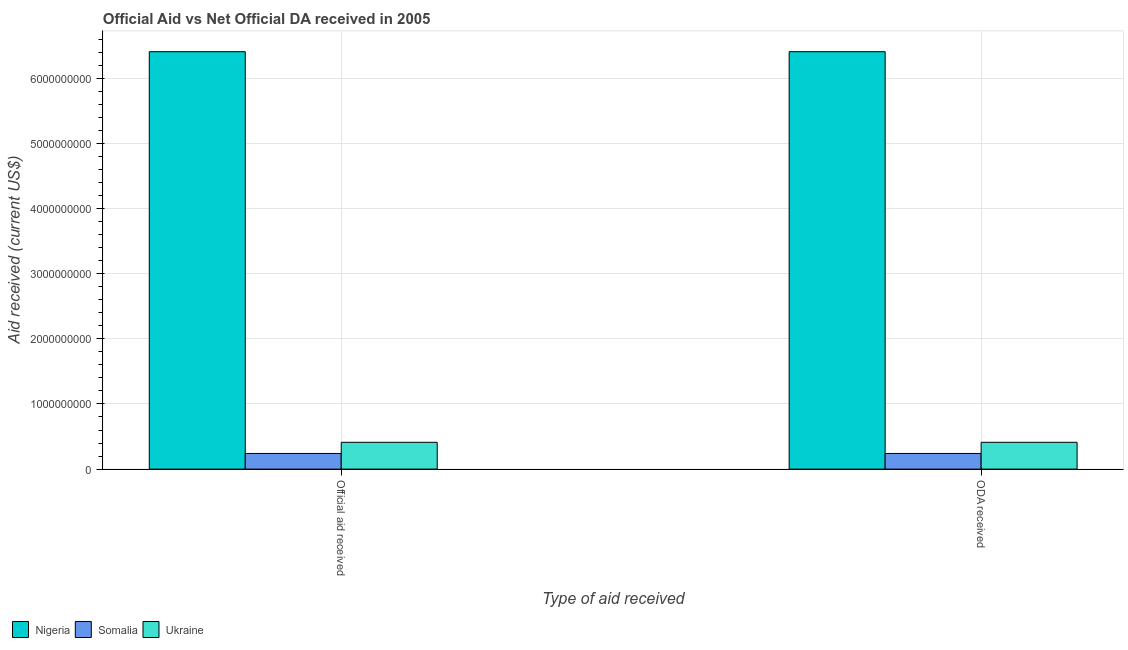How many different coloured bars are there?
Your answer should be compact. 3. Are the number of bars per tick equal to the number of legend labels?
Your response must be concise. Yes. How many bars are there on the 1st tick from the left?
Keep it short and to the point. 3. How many bars are there on the 1st tick from the right?
Ensure brevity in your answer.  3. What is the label of the 2nd group of bars from the left?
Give a very brief answer. ODA received. What is the oda received in Nigeria?
Provide a succinct answer. 6.41e+09. Across all countries, what is the maximum oda received?
Your answer should be very brief. 6.41e+09. Across all countries, what is the minimum official aid received?
Offer a terse response. 2.40e+08. In which country was the oda received maximum?
Provide a succinct answer. Nigeria. In which country was the official aid received minimum?
Your response must be concise. Somalia. What is the total oda received in the graph?
Provide a short and direct response. 7.06e+09. What is the difference between the official aid received in Ukraine and that in Somalia?
Offer a very short reply. 1.71e+08. What is the difference between the oda received in Nigeria and the official aid received in Ukraine?
Offer a terse response. 6.00e+09. What is the average oda received per country?
Provide a succinct answer. 2.35e+09. What is the ratio of the official aid received in Nigeria to that in Somalia?
Your answer should be compact. 26.68. Is the official aid received in Ukraine less than that in Nigeria?
Give a very brief answer. Yes. What does the 3rd bar from the left in ODA received represents?
Your response must be concise. Ukraine. What does the 3rd bar from the right in Official aid received represents?
Provide a succinct answer. Nigeria. Are the values on the major ticks of Y-axis written in scientific E-notation?
Your response must be concise. No. Does the graph contain any zero values?
Give a very brief answer. No. How are the legend labels stacked?
Provide a short and direct response. Horizontal. What is the title of the graph?
Keep it short and to the point. Official Aid vs Net Official DA received in 2005 . What is the label or title of the X-axis?
Provide a short and direct response. Type of aid received. What is the label or title of the Y-axis?
Provide a succinct answer. Aid received (current US$). What is the Aid received (current US$) in Nigeria in Official aid received?
Offer a terse response. 6.41e+09. What is the Aid received (current US$) in Somalia in Official aid received?
Your answer should be compact. 2.40e+08. What is the Aid received (current US$) in Ukraine in Official aid received?
Give a very brief answer. 4.12e+08. What is the Aid received (current US$) in Nigeria in ODA received?
Provide a succinct answer. 6.41e+09. What is the Aid received (current US$) in Somalia in ODA received?
Offer a terse response. 2.40e+08. What is the Aid received (current US$) in Ukraine in ODA received?
Give a very brief answer. 4.12e+08. Across all Type of aid received, what is the maximum Aid received (current US$) of Nigeria?
Offer a terse response. 6.41e+09. Across all Type of aid received, what is the maximum Aid received (current US$) in Somalia?
Your answer should be compact. 2.40e+08. Across all Type of aid received, what is the maximum Aid received (current US$) in Ukraine?
Give a very brief answer. 4.12e+08. Across all Type of aid received, what is the minimum Aid received (current US$) in Nigeria?
Make the answer very short. 6.41e+09. Across all Type of aid received, what is the minimum Aid received (current US$) of Somalia?
Offer a terse response. 2.40e+08. Across all Type of aid received, what is the minimum Aid received (current US$) of Ukraine?
Provide a succinct answer. 4.12e+08. What is the total Aid received (current US$) of Nigeria in the graph?
Give a very brief answer. 1.28e+1. What is the total Aid received (current US$) of Somalia in the graph?
Your answer should be compact. 4.80e+08. What is the total Aid received (current US$) of Ukraine in the graph?
Provide a short and direct response. 8.23e+08. What is the difference between the Aid received (current US$) of Somalia in Official aid received and that in ODA received?
Offer a very short reply. 0. What is the difference between the Aid received (current US$) in Nigeria in Official aid received and the Aid received (current US$) in Somalia in ODA received?
Offer a terse response. 6.17e+09. What is the difference between the Aid received (current US$) in Nigeria in Official aid received and the Aid received (current US$) in Ukraine in ODA received?
Your answer should be very brief. 6.00e+09. What is the difference between the Aid received (current US$) in Somalia in Official aid received and the Aid received (current US$) in Ukraine in ODA received?
Make the answer very short. -1.71e+08. What is the average Aid received (current US$) in Nigeria per Type of aid received?
Give a very brief answer. 6.41e+09. What is the average Aid received (current US$) of Somalia per Type of aid received?
Offer a terse response. 2.40e+08. What is the average Aid received (current US$) of Ukraine per Type of aid received?
Give a very brief answer. 4.12e+08. What is the difference between the Aid received (current US$) in Nigeria and Aid received (current US$) in Somalia in Official aid received?
Make the answer very short. 6.17e+09. What is the difference between the Aid received (current US$) in Nigeria and Aid received (current US$) in Ukraine in Official aid received?
Your answer should be very brief. 6.00e+09. What is the difference between the Aid received (current US$) of Somalia and Aid received (current US$) of Ukraine in Official aid received?
Keep it short and to the point. -1.71e+08. What is the difference between the Aid received (current US$) of Nigeria and Aid received (current US$) of Somalia in ODA received?
Keep it short and to the point. 6.17e+09. What is the difference between the Aid received (current US$) of Nigeria and Aid received (current US$) of Ukraine in ODA received?
Keep it short and to the point. 6.00e+09. What is the difference between the Aid received (current US$) of Somalia and Aid received (current US$) of Ukraine in ODA received?
Provide a succinct answer. -1.71e+08. What is the ratio of the Aid received (current US$) of Ukraine in Official aid received to that in ODA received?
Provide a succinct answer. 1. What is the difference between the highest and the second highest Aid received (current US$) in Somalia?
Provide a short and direct response. 0. What is the difference between the highest and the second highest Aid received (current US$) of Ukraine?
Provide a short and direct response. 0. 